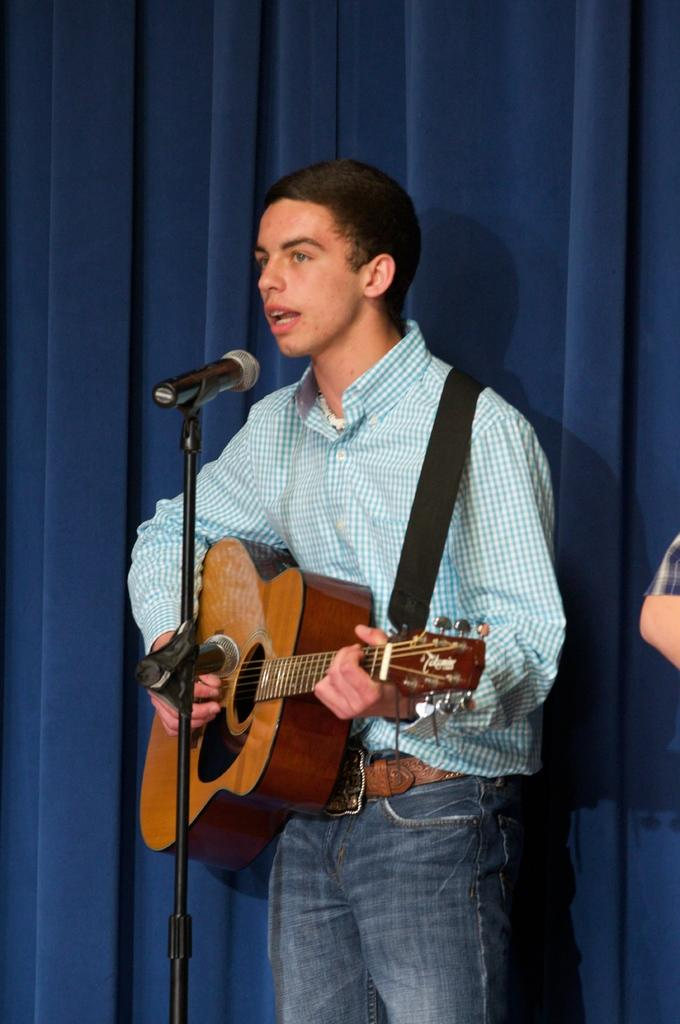What is the main subject of the image? There is a man in the image. What is the man doing in the image? The man is standing in the image. What object is the man holding? The man is holding a guitar. What is in front of the man? There is a microphone in front of the man. What can be seen in the background of the image? There is a curtain in the background of the image. What type of coat is the man wearing in the image? The man is not wearing a coat in the image. What kind of bushes can be seen in the background of the image? There are no bushes visible in the background of the image; only a curtain is present. 